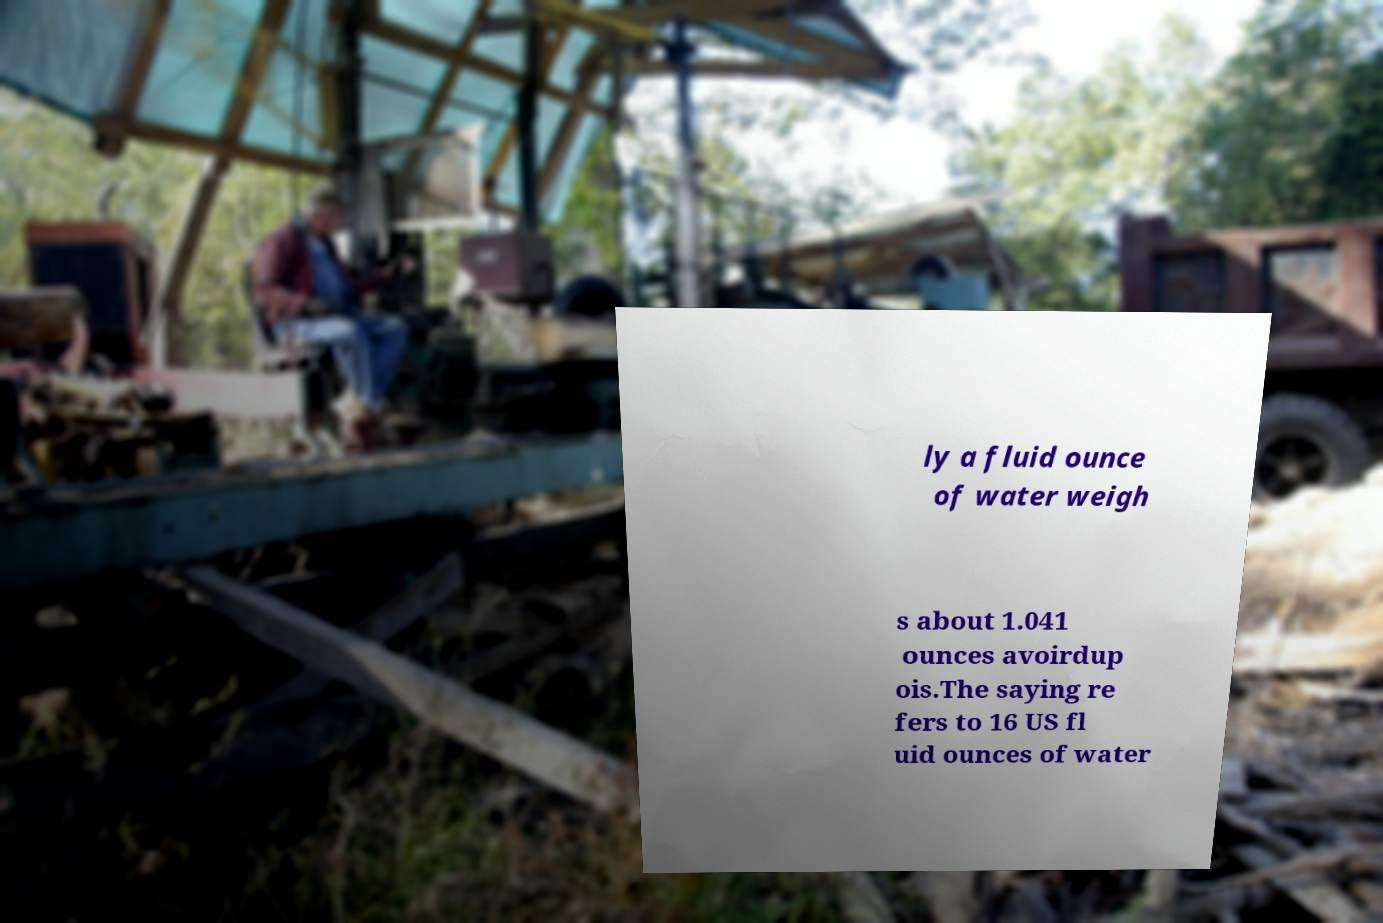I need the written content from this picture converted into text. Can you do that? ly a fluid ounce of water weigh s about 1.041 ounces avoirdup ois.The saying re fers to 16 US fl uid ounces of water 